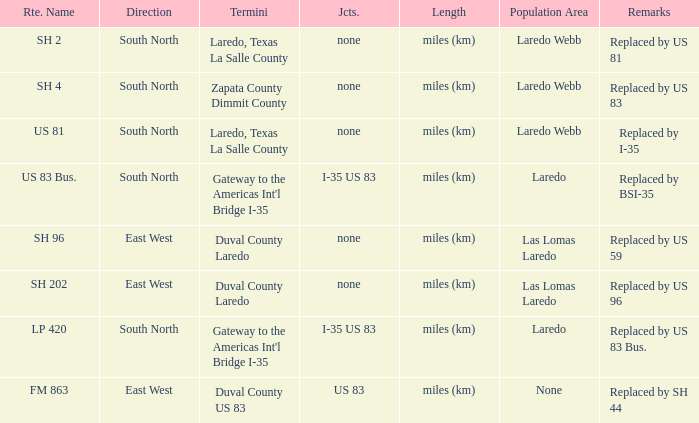What unit of length is being used for the route with "replaced by us 81" in their remarks section? Miles (km). 